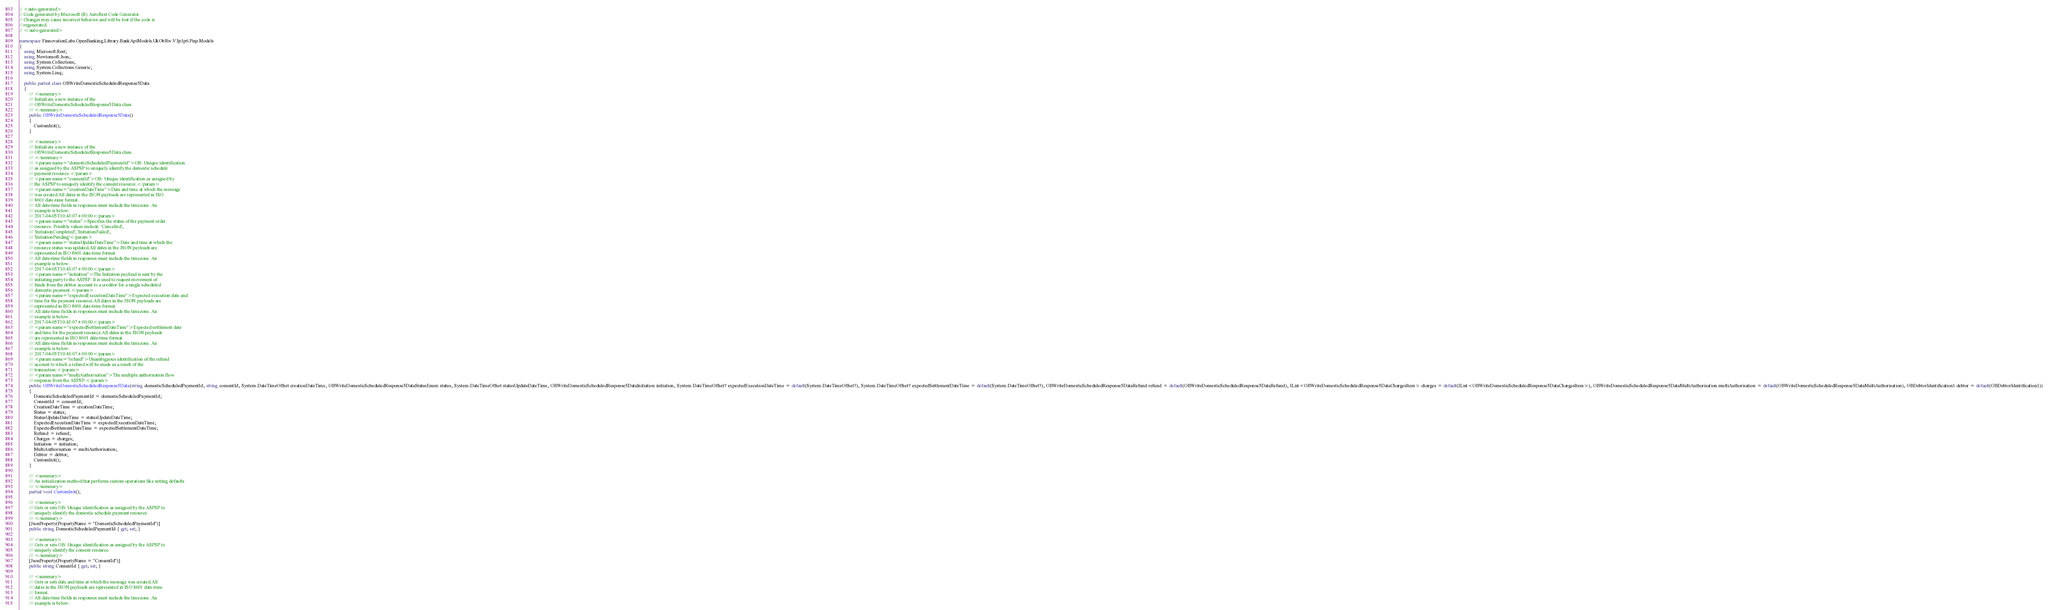Convert code to text. <code><loc_0><loc_0><loc_500><loc_500><_C#_>// <auto-generated>
// Code generated by Microsoft (R) AutoRest Code Generator.
// Changes may cause incorrect behavior and will be lost if the code is
// regenerated.
// </auto-generated>

namespace FinnovationLabs.OpenBanking.Library.BankApiModels.UkObRw.V3p1p6.Pisp.Models
{
    using Microsoft.Rest;
    using Newtonsoft.Json;
    using System.Collections;
    using System.Collections.Generic;
    using System.Linq;

    public partial class OBWriteDomesticScheduledResponse5Data
    {
        /// <summary>
        /// Initializes a new instance of the
        /// OBWriteDomesticScheduledResponse5Data class.
        /// </summary>
        public OBWriteDomesticScheduledResponse5Data()
        {
            CustomInit();
        }

        /// <summary>
        /// Initializes a new instance of the
        /// OBWriteDomesticScheduledResponse5Data class.
        /// </summary>
        /// <param name="domesticScheduledPaymentId">OB: Unique identification
        /// as assigned by the ASPSP to uniquely identify the domestic schedule
        /// payment resource.</param>
        /// <param name="consentId">OB: Unique identification as assigned by
        /// the ASPSP to uniquely identify the consent resource.</param>
        /// <param name="creationDateTime">Date and time at which the message
        /// was created.All dates in the JSON payloads are represented in ISO
        /// 8601 date-time format.
        /// All date-time fields in responses must include the timezone. An
        /// example is below:
        /// 2017-04-05T10:43:07+00:00</param>
        /// <param name="status">Specifies the status of the payment order
        /// resource. Possible values include: 'Cancelled',
        /// 'InitiationCompleted', 'InitiationFailed',
        /// 'InitiationPending'</param>
        /// <param name="statusUpdateDateTime">Date and time at which the
        /// resource status was updated.All dates in the JSON payloads are
        /// represented in ISO 8601 date-time format.
        /// All date-time fields in responses must include the timezone. An
        /// example is below:
        /// 2017-04-05T10:43:07+00:00</param>
        /// <param name="initiation">The Initiation payload is sent by the
        /// initiating party to the ASPSP. It is used to request movement of
        /// funds from the debtor account to a creditor for a single scheduled
        /// domestic payment.</param>
        /// <param name="expectedExecutionDateTime">Expected execution date and
        /// time for the payment resource.All dates in the JSON payloads are
        /// represented in ISO 8601 date-time format.
        /// All date-time fields in responses must include the timezone. An
        /// example is below:
        /// 2017-04-05T10:43:07+00:00</param>
        /// <param name="expectedSettlementDateTime">Expected settlement date
        /// and time for the payment resource.All dates in the JSON payloads
        /// are represented in ISO 8601 date-time format.
        /// All date-time fields in responses must include the timezone. An
        /// example is below:
        /// 2017-04-05T10:43:07+00:00</param>
        /// <param name="refund">Unambiguous identification of the refund
        /// account to which a refund will be made as a result of the
        /// transaction.</param>
        /// <param name="multiAuthorisation">The multiple authorisation flow
        /// response from the ASPSP.</param>
        public OBWriteDomesticScheduledResponse5Data(string domesticScheduledPaymentId, string consentId, System.DateTimeOffset creationDateTime, OBWriteDomesticScheduledResponse5DataStatusEnum status, System.DateTimeOffset statusUpdateDateTime, OBWriteDomesticScheduledResponse5DataInitiation initiation, System.DateTimeOffset? expectedExecutionDateTime = default(System.DateTimeOffset?), System.DateTimeOffset? expectedSettlementDateTime = default(System.DateTimeOffset?), OBWriteDomesticScheduledResponse5DataRefund refund = default(OBWriteDomesticScheduledResponse5DataRefund), IList<OBWriteDomesticScheduledResponse5DataChargesItem> charges = default(IList<OBWriteDomesticScheduledResponse5DataChargesItem>), OBWriteDomesticScheduledResponse5DataMultiAuthorisation multiAuthorisation = default(OBWriteDomesticScheduledResponse5DataMultiAuthorisation), OBDebtorIdentification1 debtor = default(OBDebtorIdentification1))
        {
            DomesticScheduledPaymentId = domesticScheduledPaymentId;
            ConsentId = consentId;
            CreationDateTime = creationDateTime;
            Status = status;
            StatusUpdateDateTime = statusUpdateDateTime;
            ExpectedExecutionDateTime = expectedExecutionDateTime;
            ExpectedSettlementDateTime = expectedSettlementDateTime;
            Refund = refund;
            Charges = charges;
            Initiation = initiation;
            MultiAuthorisation = multiAuthorisation;
            Debtor = debtor;
            CustomInit();
        }

        /// <summary>
        /// An initialization method that performs custom operations like setting defaults
        /// </summary>
        partial void CustomInit();

        /// <summary>
        /// Gets or sets OB: Unique identification as assigned by the ASPSP to
        /// uniquely identify the domestic schedule payment resource.
        /// </summary>
        [JsonProperty(PropertyName = "DomesticScheduledPaymentId")]
        public string DomesticScheduledPaymentId { get; set; }

        /// <summary>
        /// Gets or sets OB: Unique identification as assigned by the ASPSP to
        /// uniquely identify the consent resource.
        /// </summary>
        [JsonProperty(PropertyName = "ConsentId")]
        public string ConsentId { get; set; }

        /// <summary>
        /// Gets or sets date and time at which the message was created.All
        /// dates in the JSON payloads are represented in ISO 8601 date-time
        /// format.
        /// All date-time fields in responses must include the timezone. An
        /// example is below:</code> 